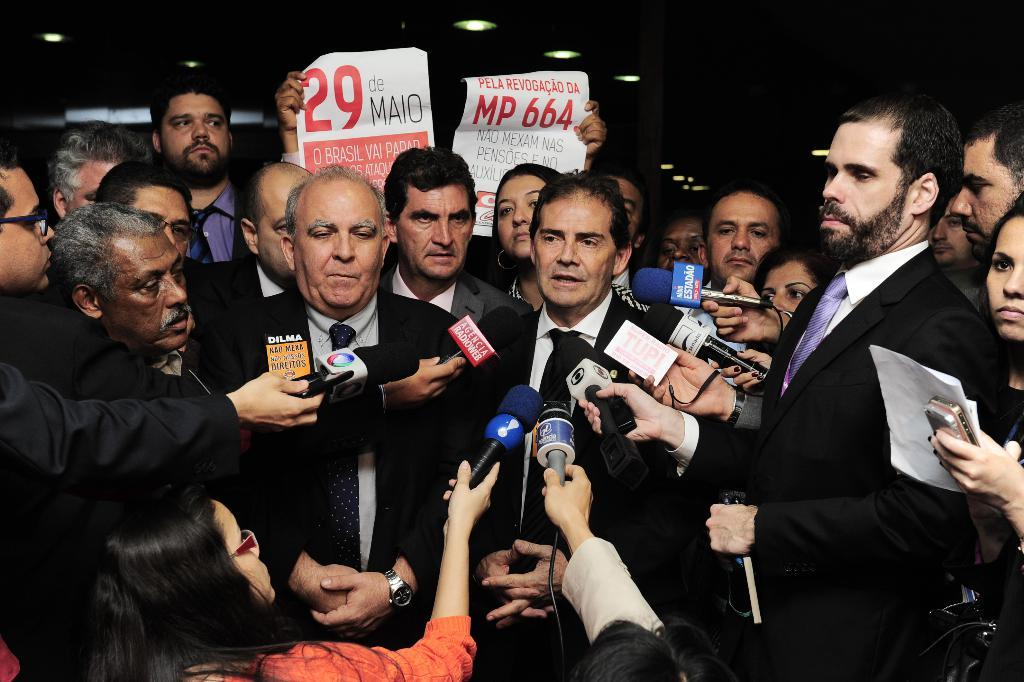What types of individuals are present in the image? There are people in the image, including men and women. What are some of the people doing in the image? Some people are holding mics in their hands. What can be observed about the lighting in the image? The background of the image is dark. What type of pen is being used by the bee in the image? There are no bees or pens present in the image. 